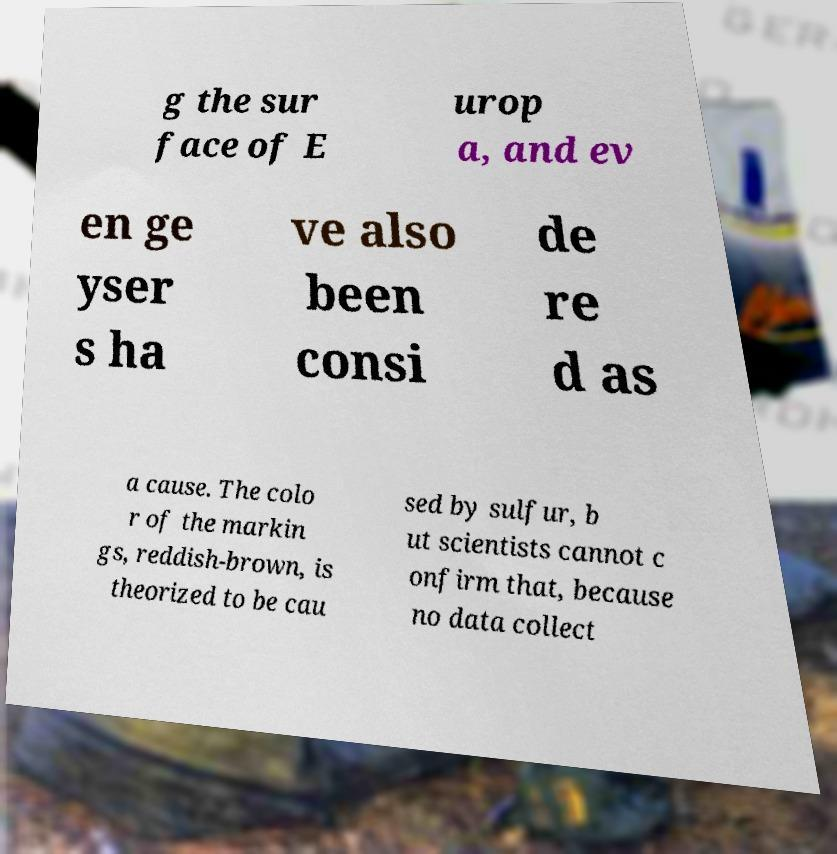There's text embedded in this image that I need extracted. Can you transcribe it verbatim? g the sur face of E urop a, and ev en ge yser s ha ve also been consi de re d as a cause. The colo r of the markin gs, reddish-brown, is theorized to be cau sed by sulfur, b ut scientists cannot c onfirm that, because no data collect 